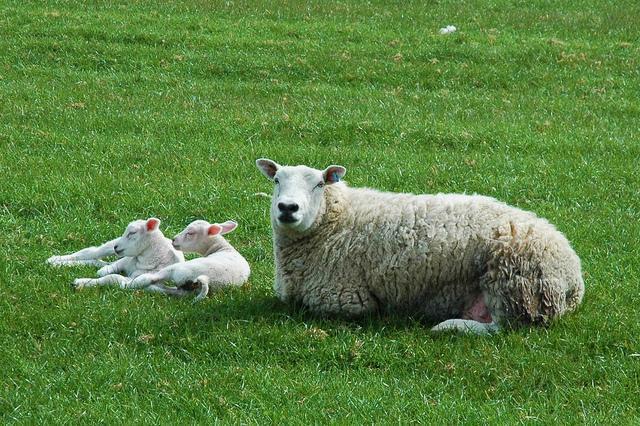How many sheep are there?
Give a very brief answer. 3. How many sheep are seen?
Give a very brief answer. 3. How many sheep are visible?
Give a very brief answer. 3. How many people are wearing glasses in the image?
Give a very brief answer. 0. 